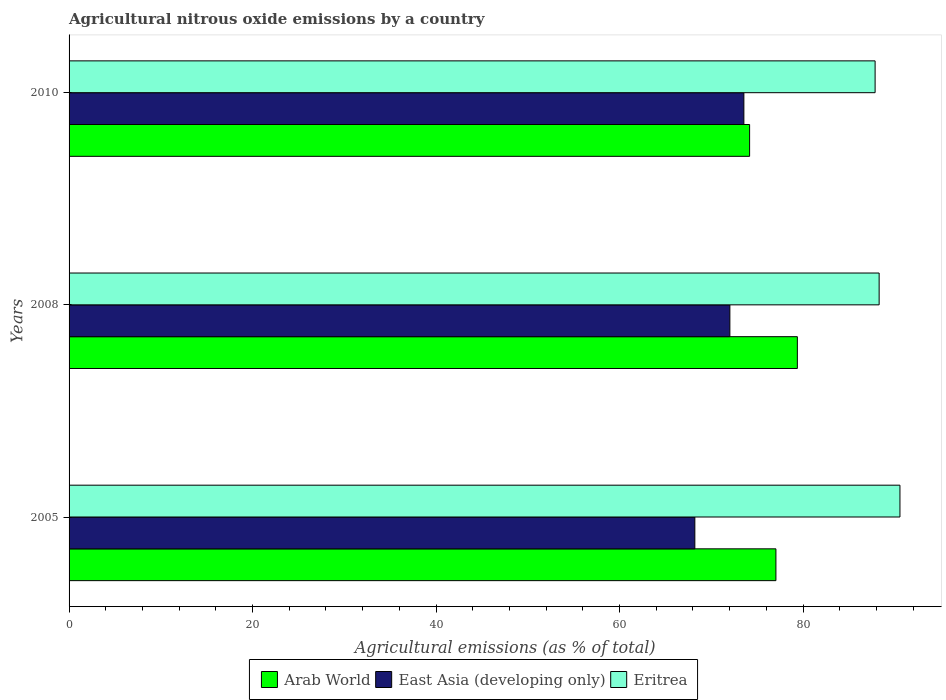How many groups of bars are there?
Make the answer very short. 3. How many bars are there on the 2nd tick from the bottom?
Ensure brevity in your answer.  3. What is the amount of agricultural nitrous oxide emitted in East Asia (developing only) in 2008?
Provide a short and direct response. 72.03. Across all years, what is the maximum amount of agricultural nitrous oxide emitted in East Asia (developing only)?
Provide a succinct answer. 73.56. Across all years, what is the minimum amount of agricultural nitrous oxide emitted in Arab World?
Offer a very short reply. 74.18. In which year was the amount of agricultural nitrous oxide emitted in Eritrea maximum?
Make the answer very short. 2005. What is the total amount of agricultural nitrous oxide emitted in East Asia (developing only) in the graph?
Keep it short and to the point. 213.8. What is the difference between the amount of agricultural nitrous oxide emitted in East Asia (developing only) in 2008 and that in 2010?
Make the answer very short. -1.53. What is the difference between the amount of agricultural nitrous oxide emitted in East Asia (developing only) in 2010 and the amount of agricultural nitrous oxide emitted in Eritrea in 2005?
Provide a succinct answer. -17.01. What is the average amount of agricultural nitrous oxide emitted in East Asia (developing only) per year?
Provide a short and direct response. 71.27. In the year 2010, what is the difference between the amount of agricultural nitrous oxide emitted in East Asia (developing only) and amount of agricultural nitrous oxide emitted in Arab World?
Provide a short and direct response. -0.62. In how many years, is the amount of agricultural nitrous oxide emitted in Arab World greater than 84 %?
Offer a terse response. 0. What is the ratio of the amount of agricultural nitrous oxide emitted in Eritrea in 2005 to that in 2008?
Make the answer very short. 1.03. Is the amount of agricultural nitrous oxide emitted in Eritrea in 2008 less than that in 2010?
Offer a terse response. No. Is the difference between the amount of agricultural nitrous oxide emitted in East Asia (developing only) in 2005 and 2008 greater than the difference between the amount of agricultural nitrous oxide emitted in Arab World in 2005 and 2008?
Give a very brief answer. No. What is the difference between the highest and the second highest amount of agricultural nitrous oxide emitted in East Asia (developing only)?
Your answer should be compact. 1.53. What is the difference between the highest and the lowest amount of agricultural nitrous oxide emitted in Eritrea?
Offer a very short reply. 2.71. Is the sum of the amount of agricultural nitrous oxide emitted in Arab World in 2005 and 2010 greater than the maximum amount of agricultural nitrous oxide emitted in Eritrea across all years?
Provide a short and direct response. Yes. What does the 1st bar from the top in 2005 represents?
Offer a terse response. Eritrea. What does the 2nd bar from the bottom in 2010 represents?
Offer a very short reply. East Asia (developing only). How many years are there in the graph?
Offer a terse response. 3. Does the graph contain grids?
Give a very brief answer. No. Where does the legend appear in the graph?
Make the answer very short. Bottom center. How are the legend labels stacked?
Give a very brief answer. Horizontal. What is the title of the graph?
Provide a succinct answer. Agricultural nitrous oxide emissions by a country. What is the label or title of the X-axis?
Ensure brevity in your answer.  Agricultural emissions (as % of total). What is the label or title of the Y-axis?
Provide a succinct answer. Years. What is the Agricultural emissions (as % of total) in Arab World in 2005?
Your answer should be very brief. 77.05. What is the Agricultural emissions (as % of total) of East Asia (developing only) in 2005?
Make the answer very short. 68.21. What is the Agricultural emissions (as % of total) in Eritrea in 2005?
Provide a short and direct response. 90.57. What is the Agricultural emissions (as % of total) of Arab World in 2008?
Make the answer very short. 79.39. What is the Agricultural emissions (as % of total) of East Asia (developing only) in 2008?
Provide a succinct answer. 72.03. What is the Agricultural emissions (as % of total) of Eritrea in 2008?
Offer a terse response. 88.3. What is the Agricultural emissions (as % of total) in Arab World in 2010?
Your response must be concise. 74.18. What is the Agricultural emissions (as % of total) in East Asia (developing only) in 2010?
Make the answer very short. 73.56. What is the Agricultural emissions (as % of total) of Eritrea in 2010?
Your response must be concise. 87.86. Across all years, what is the maximum Agricultural emissions (as % of total) of Arab World?
Your response must be concise. 79.39. Across all years, what is the maximum Agricultural emissions (as % of total) in East Asia (developing only)?
Offer a very short reply. 73.56. Across all years, what is the maximum Agricultural emissions (as % of total) in Eritrea?
Your answer should be compact. 90.57. Across all years, what is the minimum Agricultural emissions (as % of total) of Arab World?
Give a very brief answer. 74.18. Across all years, what is the minimum Agricultural emissions (as % of total) in East Asia (developing only)?
Make the answer very short. 68.21. Across all years, what is the minimum Agricultural emissions (as % of total) in Eritrea?
Give a very brief answer. 87.86. What is the total Agricultural emissions (as % of total) in Arab World in the graph?
Give a very brief answer. 230.62. What is the total Agricultural emissions (as % of total) in East Asia (developing only) in the graph?
Make the answer very short. 213.8. What is the total Agricultural emissions (as % of total) of Eritrea in the graph?
Give a very brief answer. 266.73. What is the difference between the Agricultural emissions (as % of total) in Arab World in 2005 and that in 2008?
Give a very brief answer. -2.34. What is the difference between the Agricultural emissions (as % of total) in East Asia (developing only) in 2005 and that in 2008?
Your answer should be very brief. -3.82. What is the difference between the Agricultural emissions (as % of total) in Eritrea in 2005 and that in 2008?
Your response must be concise. 2.27. What is the difference between the Agricultural emissions (as % of total) in Arab World in 2005 and that in 2010?
Offer a terse response. 2.87. What is the difference between the Agricultural emissions (as % of total) in East Asia (developing only) in 2005 and that in 2010?
Provide a short and direct response. -5.34. What is the difference between the Agricultural emissions (as % of total) of Eritrea in 2005 and that in 2010?
Provide a short and direct response. 2.71. What is the difference between the Agricultural emissions (as % of total) in Arab World in 2008 and that in 2010?
Provide a succinct answer. 5.21. What is the difference between the Agricultural emissions (as % of total) in East Asia (developing only) in 2008 and that in 2010?
Ensure brevity in your answer.  -1.53. What is the difference between the Agricultural emissions (as % of total) in Eritrea in 2008 and that in 2010?
Give a very brief answer. 0.44. What is the difference between the Agricultural emissions (as % of total) of Arab World in 2005 and the Agricultural emissions (as % of total) of East Asia (developing only) in 2008?
Provide a succinct answer. 5.02. What is the difference between the Agricultural emissions (as % of total) of Arab World in 2005 and the Agricultural emissions (as % of total) of Eritrea in 2008?
Provide a short and direct response. -11.25. What is the difference between the Agricultural emissions (as % of total) in East Asia (developing only) in 2005 and the Agricultural emissions (as % of total) in Eritrea in 2008?
Ensure brevity in your answer.  -20.09. What is the difference between the Agricultural emissions (as % of total) in Arab World in 2005 and the Agricultural emissions (as % of total) in East Asia (developing only) in 2010?
Provide a succinct answer. 3.49. What is the difference between the Agricultural emissions (as % of total) in Arab World in 2005 and the Agricultural emissions (as % of total) in Eritrea in 2010?
Your answer should be very brief. -10.81. What is the difference between the Agricultural emissions (as % of total) of East Asia (developing only) in 2005 and the Agricultural emissions (as % of total) of Eritrea in 2010?
Offer a very short reply. -19.65. What is the difference between the Agricultural emissions (as % of total) of Arab World in 2008 and the Agricultural emissions (as % of total) of East Asia (developing only) in 2010?
Offer a terse response. 5.83. What is the difference between the Agricultural emissions (as % of total) of Arab World in 2008 and the Agricultural emissions (as % of total) of Eritrea in 2010?
Provide a short and direct response. -8.47. What is the difference between the Agricultural emissions (as % of total) in East Asia (developing only) in 2008 and the Agricultural emissions (as % of total) in Eritrea in 2010?
Your answer should be compact. -15.83. What is the average Agricultural emissions (as % of total) in Arab World per year?
Offer a terse response. 76.87. What is the average Agricultural emissions (as % of total) of East Asia (developing only) per year?
Give a very brief answer. 71.27. What is the average Agricultural emissions (as % of total) of Eritrea per year?
Offer a terse response. 88.91. In the year 2005, what is the difference between the Agricultural emissions (as % of total) of Arab World and Agricultural emissions (as % of total) of East Asia (developing only)?
Offer a very short reply. 8.84. In the year 2005, what is the difference between the Agricultural emissions (as % of total) of Arab World and Agricultural emissions (as % of total) of Eritrea?
Make the answer very short. -13.52. In the year 2005, what is the difference between the Agricultural emissions (as % of total) of East Asia (developing only) and Agricultural emissions (as % of total) of Eritrea?
Provide a short and direct response. -22.36. In the year 2008, what is the difference between the Agricultural emissions (as % of total) of Arab World and Agricultural emissions (as % of total) of East Asia (developing only)?
Offer a terse response. 7.36. In the year 2008, what is the difference between the Agricultural emissions (as % of total) in Arab World and Agricultural emissions (as % of total) in Eritrea?
Your response must be concise. -8.91. In the year 2008, what is the difference between the Agricultural emissions (as % of total) in East Asia (developing only) and Agricultural emissions (as % of total) in Eritrea?
Your response must be concise. -16.27. In the year 2010, what is the difference between the Agricultural emissions (as % of total) of Arab World and Agricultural emissions (as % of total) of East Asia (developing only)?
Make the answer very short. 0.62. In the year 2010, what is the difference between the Agricultural emissions (as % of total) of Arab World and Agricultural emissions (as % of total) of Eritrea?
Provide a short and direct response. -13.68. In the year 2010, what is the difference between the Agricultural emissions (as % of total) in East Asia (developing only) and Agricultural emissions (as % of total) in Eritrea?
Keep it short and to the point. -14.3. What is the ratio of the Agricultural emissions (as % of total) in Arab World in 2005 to that in 2008?
Make the answer very short. 0.97. What is the ratio of the Agricultural emissions (as % of total) in East Asia (developing only) in 2005 to that in 2008?
Provide a succinct answer. 0.95. What is the ratio of the Agricultural emissions (as % of total) in Eritrea in 2005 to that in 2008?
Give a very brief answer. 1.03. What is the ratio of the Agricultural emissions (as % of total) of Arab World in 2005 to that in 2010?
Your response must be concise. 1.04. What is the ratio of the Agricultural emissions (as % of total) of East Asia (developing only) in 2005 to that in 2010?
Make the answer very short. 0.93. What is the ratio of the Agricultural emissions (as % of total) in Eritrea in 2005 to that in 2010?
Keep it short and to the point. 1.03. What is the ratio of the Agricultural emissions (as % of total) in Arab World in 2008 to that in 2010?
Offer a very short reply. 1.07. What is the ratio of the Agricultural emissions (as % of total) in East Asia (developing only) in 2008 to that in 2010?
Provide a succinct answer. 0.98. What is the difference between the highest and the second highest Agricultural emissions (as % of total) of Arab World?
Your answer should be compact. 2.34. What is the difference between the highest and the second highest Agricultural emissions (as % of total) in East Asia (developing only)?
Provide a succinct answer. 1.53. What is the difference between the highest and the second highest Agricultural emissions (as % of total) in Eritrea?
Offer a very short reply. 2.27. What is the difference between the highest and the lowest Agricultural emissions (as % of total) in Arab World?
Give a very brief answer. 5.21. What is the difference between the highest and the lowest Agricultural emissions (as % of total) in East Asia (developing only)?
Offer a very short reply. 5.34. What is the difference between the highest and the lowest Agricultural emissions (as % of total) in Eritrea?
Provide a succinct answer. 2.71. 